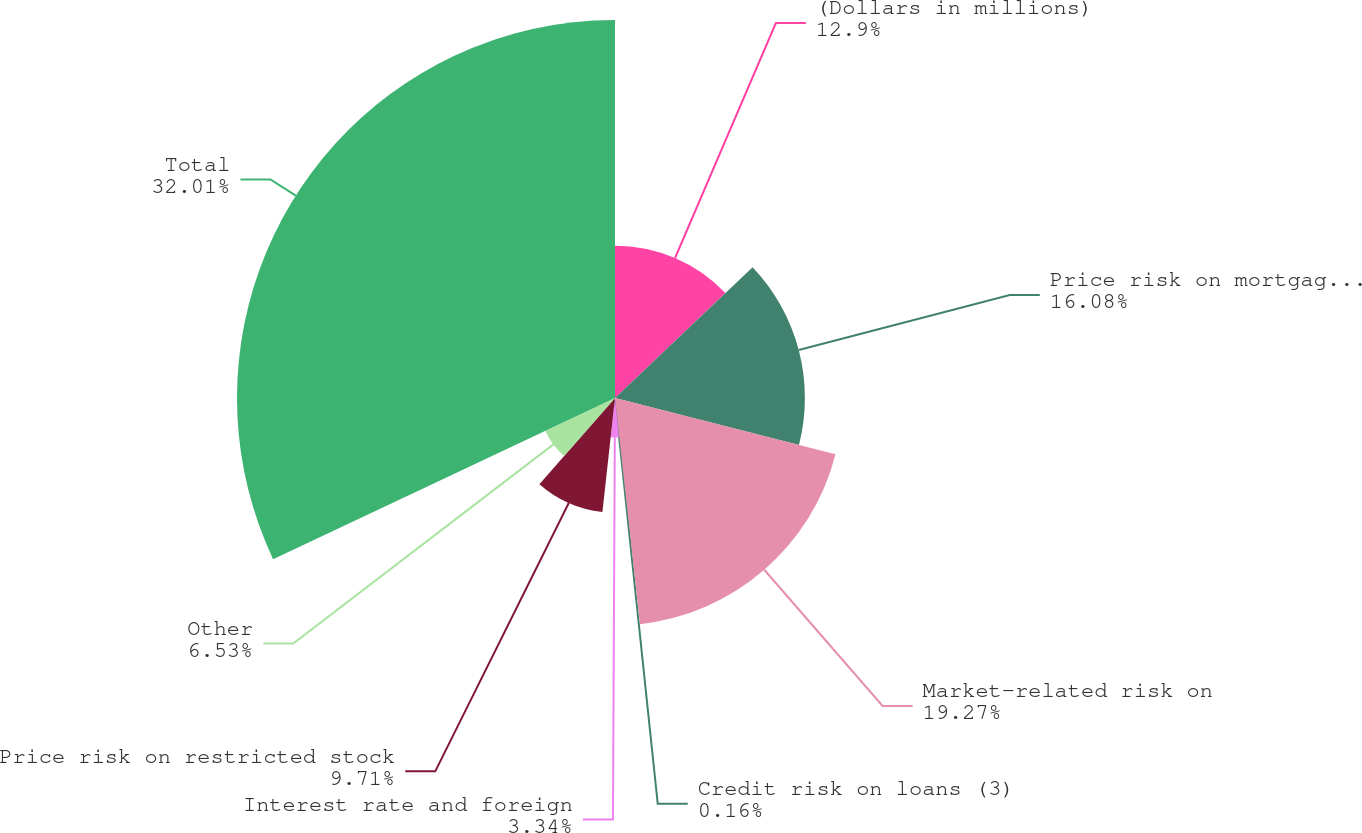<chart> <loc_0><loc_0><loc_500><loc_500><pie_chart><fcel>(Dollars in millions)<fcel>Price risk on mortgage banking<fcel>Market-related risk on<fcel>Credit risk on loans (3)<fcel>Interest rate and foreign<fcel>Price risk on restricted stock<fcel>Other<fcel>Total<nl><fcel>12.9%<fcel>16.08%<fcel>19.27%<fcel>0.16%<fcel>3.34%<fcel>9.71%<fcel>6.53%<fcel>32.01%<nl></chart> 